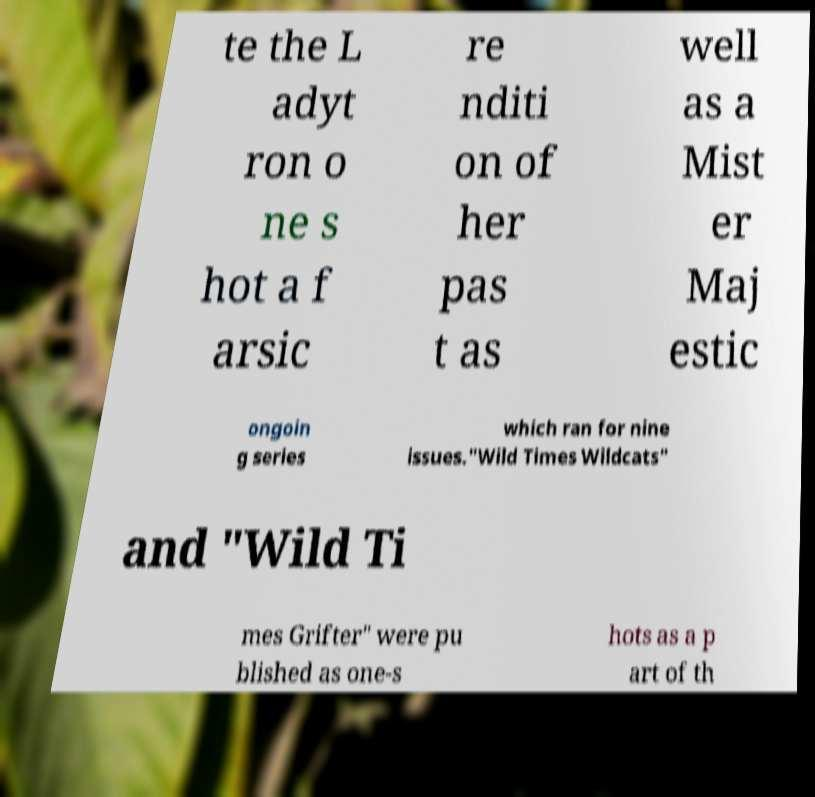Can you read and provide the text displayed in the image?This photo seems to have some interesting text. Can you extract and type it out for me? te the L adyt ron o ne s hot a f arsic re nditi on of her pas t as well as a Mist er Maj estic ongoin g series which ran for nine issues."Wild Times Wildcats" and "Wild Ti mes Grifter" were pu blished as one-s hots as a p art of th 